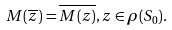Convert formula to latex. <formula><loc_0><loc_0><loc_500><loc_500>M ( \overline { z } ) = \overline { M ( z ) } , z \in \rho ( S _ { 0 } ) .</formula> 